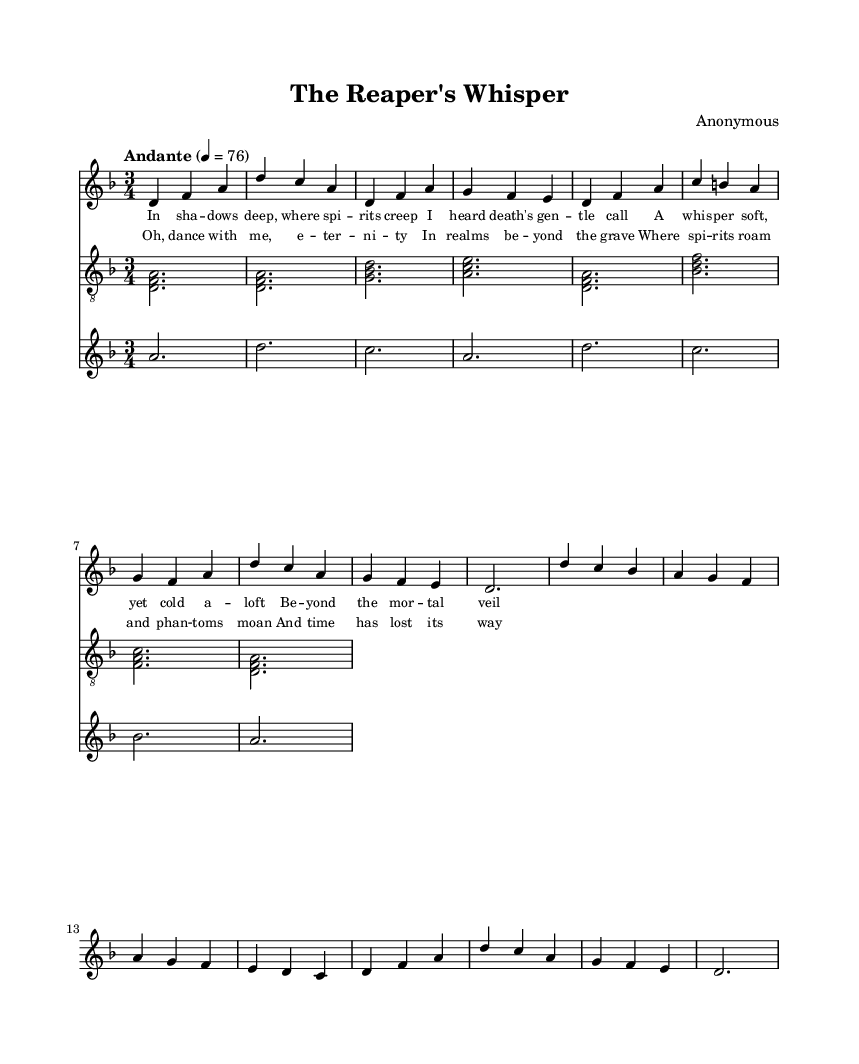What is the key signature of this music? The key signature is indicated by the presence of B-flat (the only flat shown), which signifies the key of D minor.
Answer: D minor What is the time signature of this music? The time signature is shown at the beginning of the score as 3/4, indicating three beats per measure and a quarter note receives one beat.
Answer: 3/4 What is the tempo marking of this music? The tempo marking indicates "Andante" with a metronome marking of 76, which signifies a moderately slow tempo.
Answer: Andante How many measures are there in the voice part? Counting the measures in the vocal line, there are eight measures in total.
Answer: 8 Describe the lyrical theme of the chorus. The chorus reflects themes of eternity, spirits, and the transcendence of death, encapsulating a dance with eternity beyond the grave.
Answer: Eternity and spirits Which instruments are included in the score? The score includes a voice, guitar, and violin, each notated on its own staff.
Answer: Voice, guitar, violin What is the starting pitch of the violin part? The starting pitch for the violin part is A, which is indicated at the beginning of the second staff.
Answer: A 